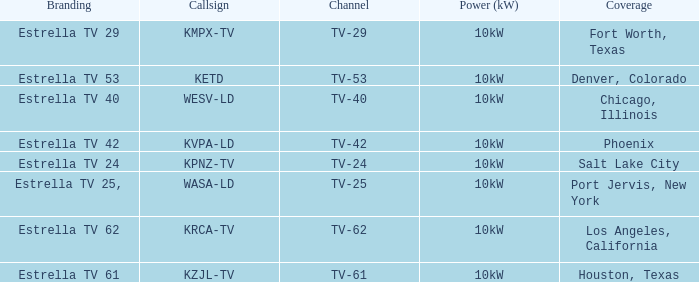What's the power output for channel tv-29? 10kW. 